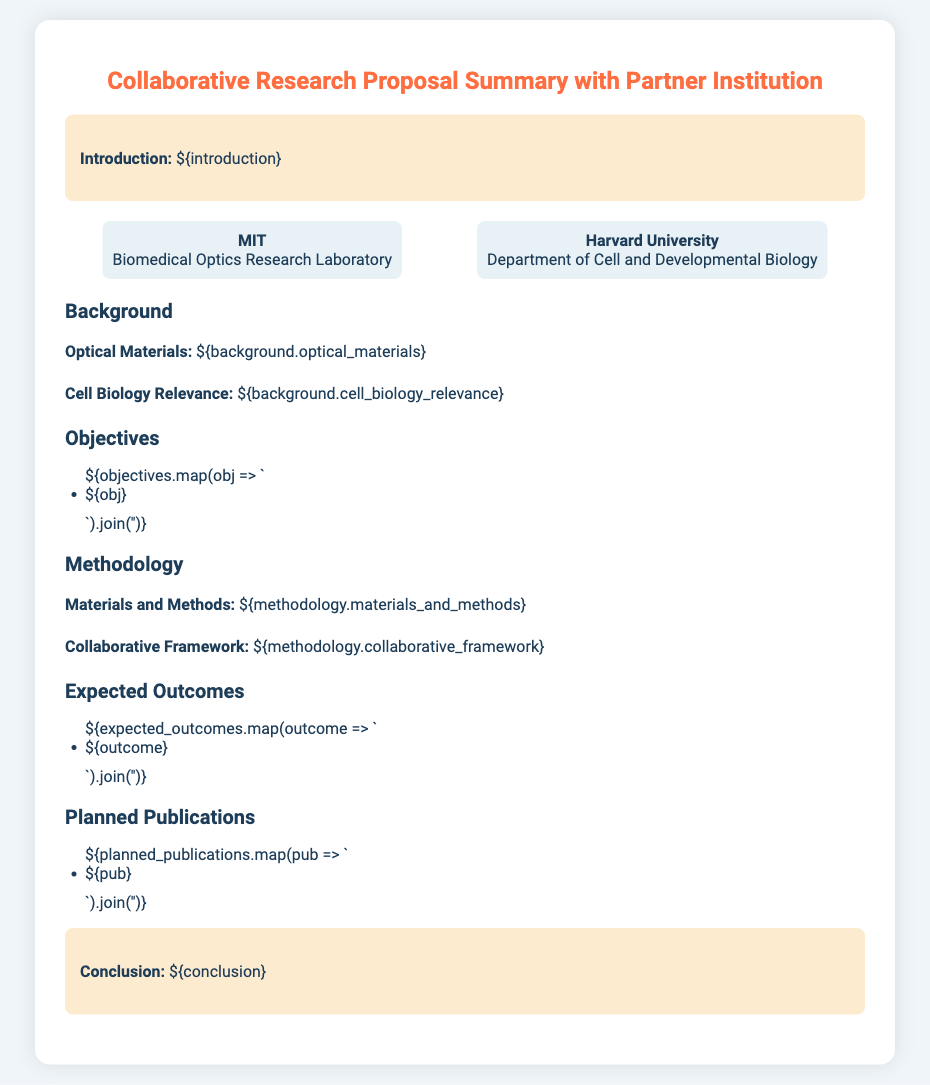What is the title of the document? The title is found in the heading of the document.
Answer: Collaborative Research Proposal Summary with Partner Institution Who are the collaborating institutions mentioned? The document lists the names of the institutions involved in the collaboration.
Answer: MIT and Harvard University What is the focus of the Optical Materials section? This section provides details about the optical materials relevant to the research.
Answer: ${background.optical_materials} What is one of the objectives outlined in the proposal? The objectives are listed in bullet points under a specific heading.
Answer: ${objectives[0]} What does the conclusion emphasize? The conclusion summarizes the overall findings or implications of the proposal content.
Answer: ${conclusion} How many planned publications are listed? The number of publications is determined by counting the items listed under the Planned Publications section.
Answer: ${planned_publications.length} What are the expected outcomes of the research? The expected outcomes are provided in a list format within the document.
Answer: ${expected_outcomes[0]} What type of research is being summarized in this proposal? The document type is indicated in the title and is specific to research collaboration.
Answer: Collaborative research 